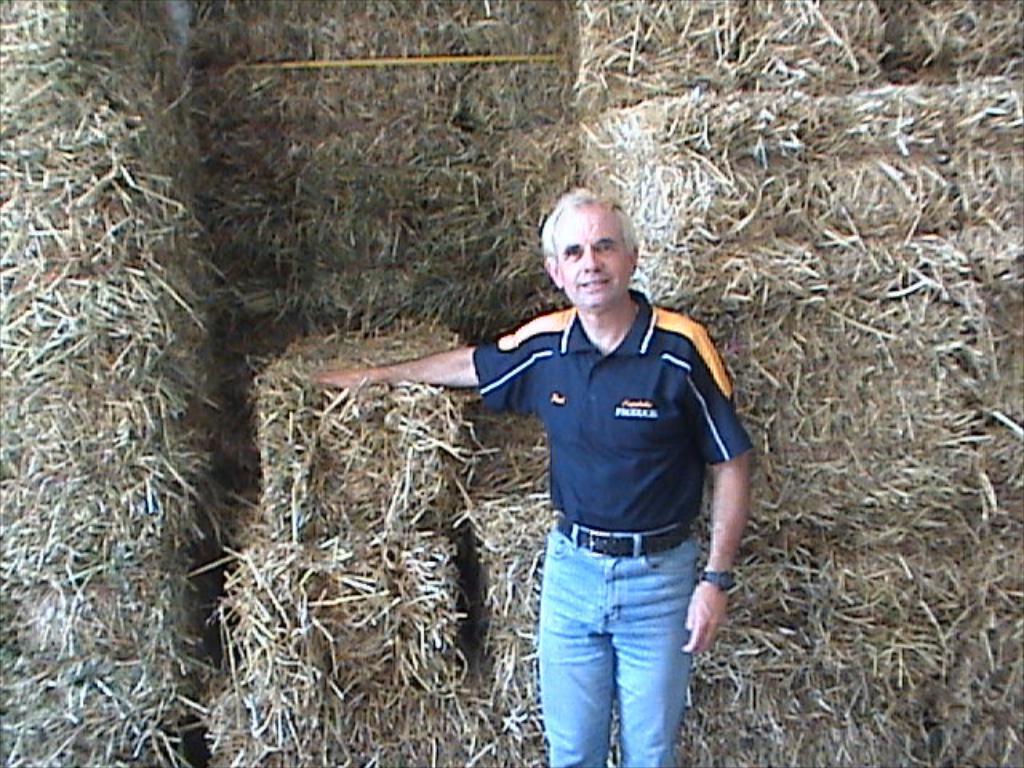Describe this image in one or two sentences. In the picture we can see a man standing with a blue T-shirt and a jeans trouser and a belt and in the background, we can see a dried grass arranged in the cubes. 